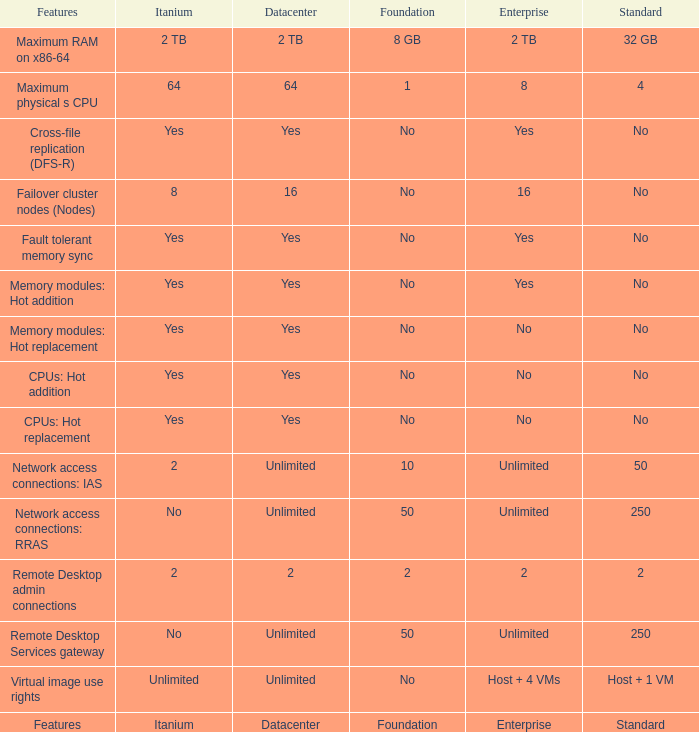Which Features have Yes listed under Datacenter? Cross-file replication (DFS-R), Fault tolerant memory sync, Memory modules: Hot addition, Memory modules: Hot replacement, CPUs: Hot addition, CPUs: Hot replacement. 